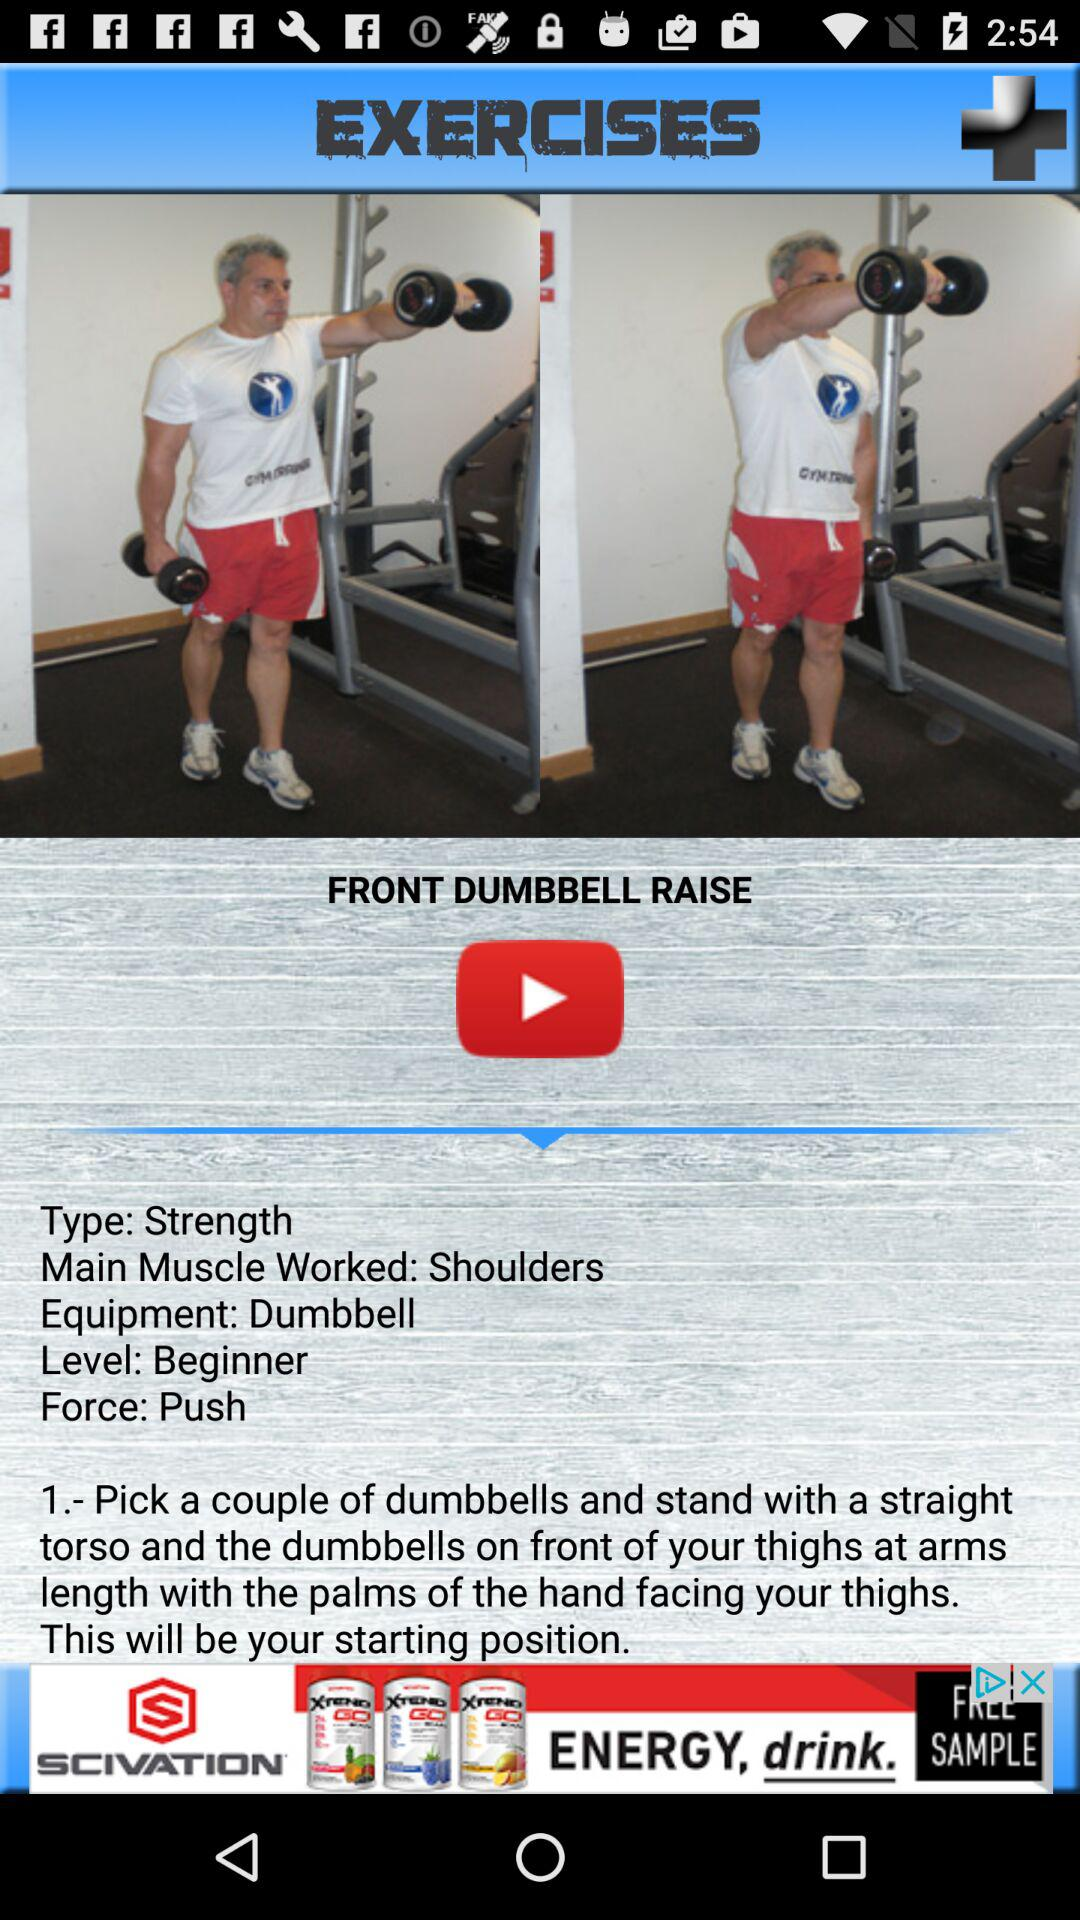What is the name of the exercise? The name of the exercise is "FRONT DUMBBELL RAISE". 